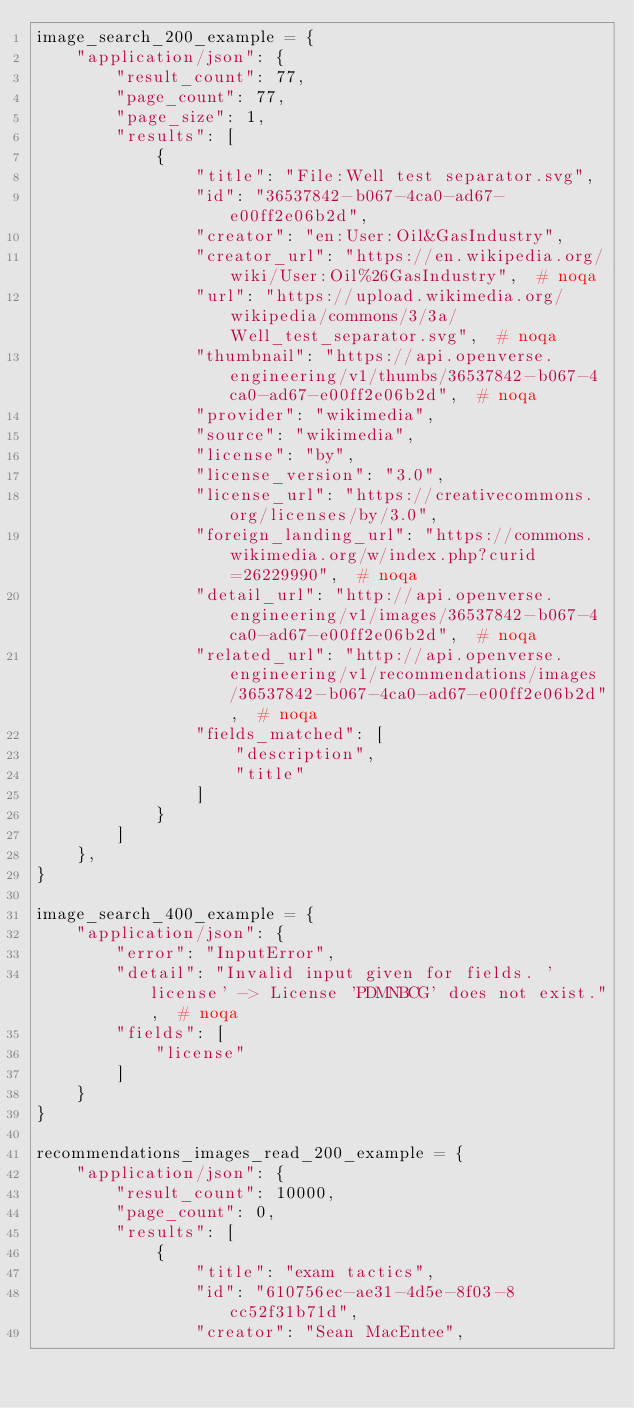<code> <loc_0><loc_0><loc_500><loc_500><_Python_>image_search_200_example = {
    "application/json": {
        "result_count": 77,
        "page_count": 77,
        "page_size": 1,
        "results": [
            {
                "title": "File:Well test separator.svg",
                "id": "36537842-b067-4ca0-ad67-e00ff2e06b2d",
                "creator": "en:User:Oil&GasIndustry",
                "creator_url": "https://en.wikipedia.org/wiki/User:Oil%26GasIndustry",  # noqa
                "url": "https://upload.wikimedia.org/wikipedia/commons/3/3a/Well_test_separator.svg",  # noqa
                "thumbnail": "https://api.openverse.engineering/v1/thumbs/36537842-b067-4ca0-ad67-e00ff2e06b2d",  # noqa
                "provider": "wikimedia",
                "source": "wikimedia",
                "license": "by",
                "license_version": "3.0",
                "license_url": "https://creativecommons.org/licenses/by/3.0",
                "foreign_landing_url": "https://commons.wikimedia.org/w/index.php?curid=26229990",  # noqa
                "detail_url": "http://api.openverse.engineering/v1/images/36537842-b067-4ca0-ad67-e00ff2e06b2d",  # noqa
                "related_url": "http://api.openverse.engineering/v1/recommendations/images/36537842-b067-4ca0-ad67-e00ff2e06b2d",  # noqa
                "fields_matched": [
                    "description",
                    "title"
                ]
            }
        ]
    },
}

image_search_400_example = {
    "application/json": {
        "error": "InputError",
        "detail": "Invalid input given for fields. 'license' -> License 'PDMNBCG' does not exist.",  # noqa
        "fields": [
            "license"
        ]
    }
}

recommendations_images_read_200_example = {
    "application/json": {
        "result_count": 10000,
        "page_count": 0,
        "results": [
            {
                "title": "exam tactics",
                "id": "610756ec-ae31-4d5e-8f03-8cc52f31b71d",
                "creator": "Sean MacEntee",</code> 